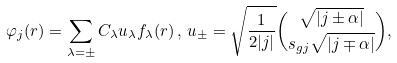Convert formula to latex. <formula><loc_0><loc_0><loc_500><loc_500>\varphi _ { j } ( r ) = \sum _ { \lambda = \pm } C _ { \lambda } u _ { \lambda } f _ { \lambda } ( r ) \, , \, u _ { \pm } = \sqrt { \frac { 1 } { 2 | j | } } \binom { \sqrt { | j \pm \alpha | } } { s _ { g j } \sqrt { | j \mp \alpha | } } ,</formula> 